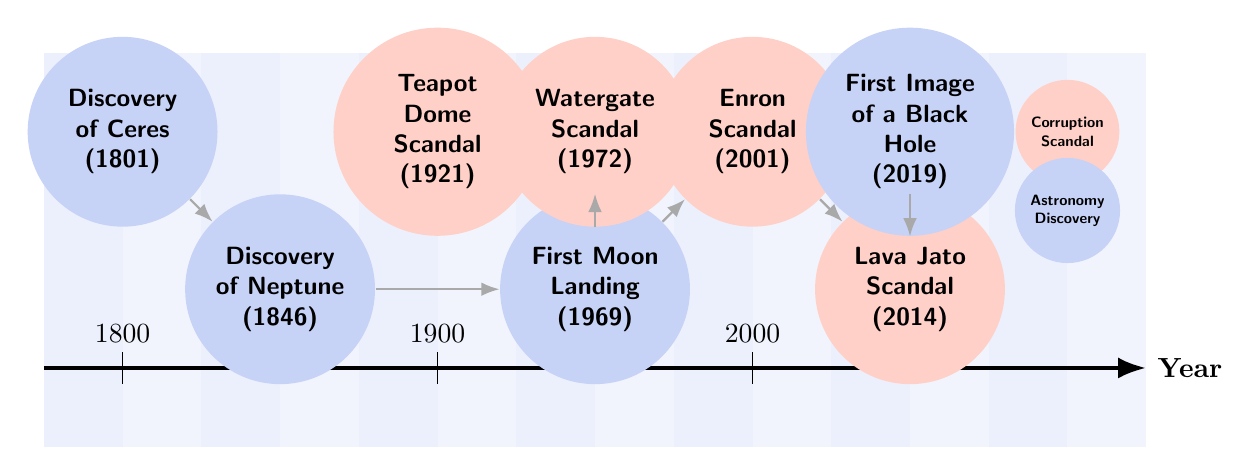What year was the first moon landing? According to the diagram, the node labeled "First Moon Landing" is at the position corresponding to the year 1969.
Answer: 1969 How many corruption scandals are depicted in the diagram? By examining the nodes categorized as "Corruption Scandal" in the diagram, there are a total of four such nodes: Teapot Dome, Watergate, Enron, and Lava Jato.
Answer: 4 Which scandal occurred in 2001? The node labeled "Enron Scandal" is specifically marked for the year 2001, making it the answer to this question.
Answer: Enron Scandal What is the first astronomy discovery listed in the timeline? The first node placed at the leftmost position of the timeline is labeled "Discovery of Ceres," which corresponds to the year 1801.
Answer: Discovery of Ceres What discovery is linked to the Enron scandal in the diagram? The diagram shows a directed edge pointing from the "Enron Scandal" node to the "Lava Jato Scandal" node, indicating that they are sequential events within the timeline.
Answer: Lava Jato Scandal What event follows the discovery of Neptune? By looking at the edges in the diagram, the event that immediately comes after the "Discovery of Neptune" is the "First Moon Landing."
Answer: First Moon Landing Which scandal is located closest to the year 2019? Observing the diagram, the node labeled "First Image of a Black Hole," which corresponds to the year 2019, is the closest event to that year.
Answer: First Image of a Black Hole How are the Watergate scandal and the first moon landing connected? According to the edge relationships in the diagram, there is a direct connection represented by an edge between the "Watergate Scandal" and the "First Moon Landing," signifying a timeline association.
Answer: Direct connection What color scheme differentiates corruption scandals from astronomy discoveries? The corruption scandals are colored in a light variant of a reddish shade (corruptionColor), while the astronomy discoveries are showcasing a light blueish shade (astronomyColor) in the diagram.
Answer: Corruption in reddish, Astronomy in blueish 